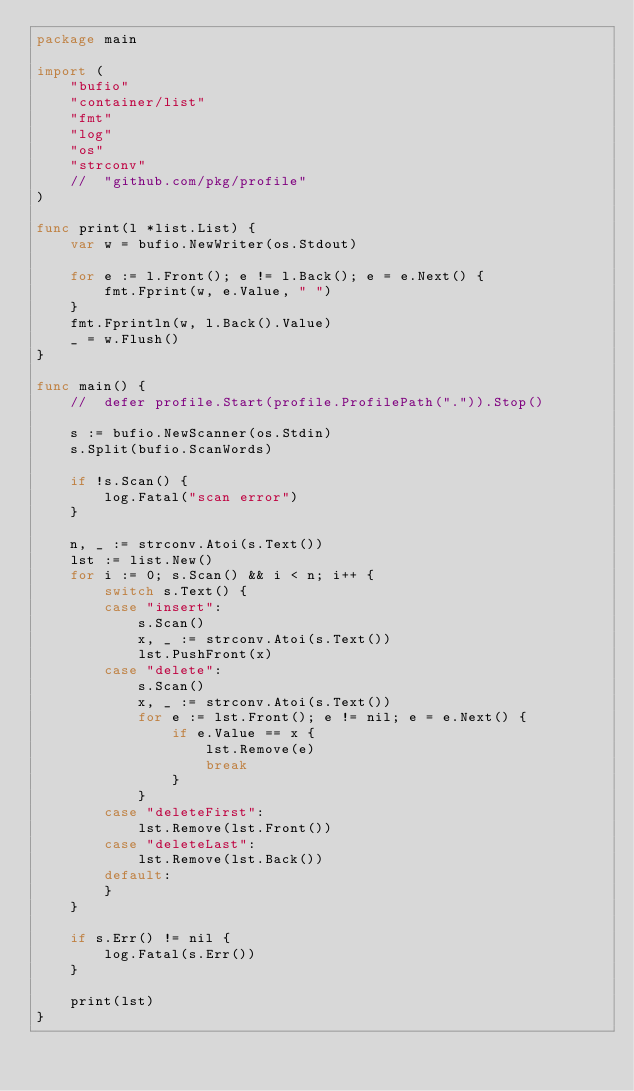<code> <loc_0><loc_0><loc_500><loc_500><_Go_>package main

import (
	"bufio"
	"container/list"
	"fmt"
	"log"
	"os"
	"strconv"
	//	"github.com/pkg/profile"
)

func print(l *list.List) {
	var w = bufio.NewWriter(os.Stdout)

	for e := l.Front(); e != l.Back(); e = e.Next() {
		fmt.Fprint(w, e.Value, " ")
	}
	fmt.Fprintln(w, l.Back().Value)
	_ = w.Flush()
}

func main() {
	//	defer profile.Start(profile.ProfilePath(".")).Stop()

	s := bufio.NewScanner(os.Stdin)
	s.Split(bufio.ScanWords)

	if !s.Scan() {
		log.Fatal("scan error")
	}

	n, _ := strconv.Atoi(s.Text())
	lst := list.New()
	for i := 0; s.Scan() && i < n; i++ {
		switch s.Text() {
		case "insert":
			s.Scan()
			x, _ := strconv.Atoi(s.Text())
			lst.PushFront(x)
		case "delete":
			s.Scan()
			x, _ := strconv.Atoi(s.Text())
			for e := lst.Front(); e != nil; e = e.Next() {
				if e.Value == x {
					lst.Remove(e)
					break
				}
			}
		case "deleteFirst":
			lst.Remove(lst.Front())
		case "deleteLast":
			lst.Remove(lst.Back())
		default:
		}
	}

	if s.Err() != nil {
		log.Fatal(s.Err())
	}

	print(lst)
}

</code> 